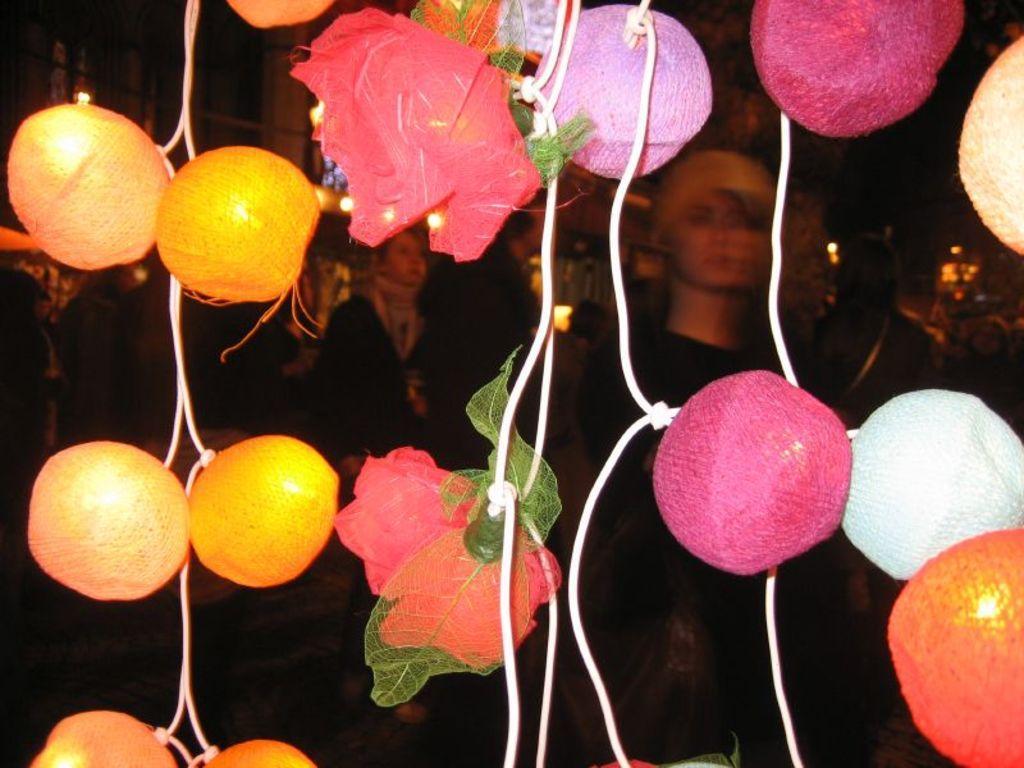How would you summarize this image in a sentence or two? In the image we can see these are the decorative balls and flowers. There are even people wearing clothes, this is a light. 